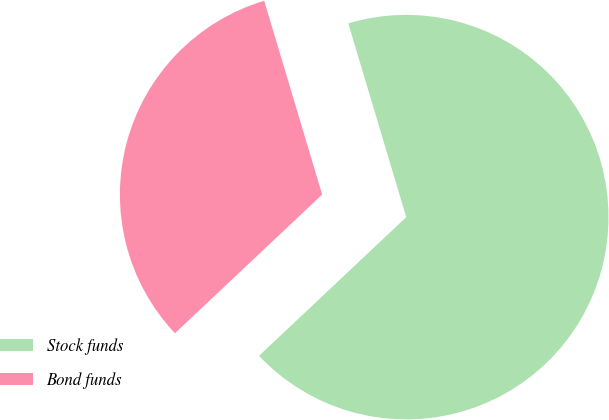Convert chart. <chart><loc_0><loc_0><loc_500><loc_500><pie_chart><fcel>Stock funds<fcel>Bond funds<nl><fcel>67.6%<fcel>32.4%<nl></chart> 